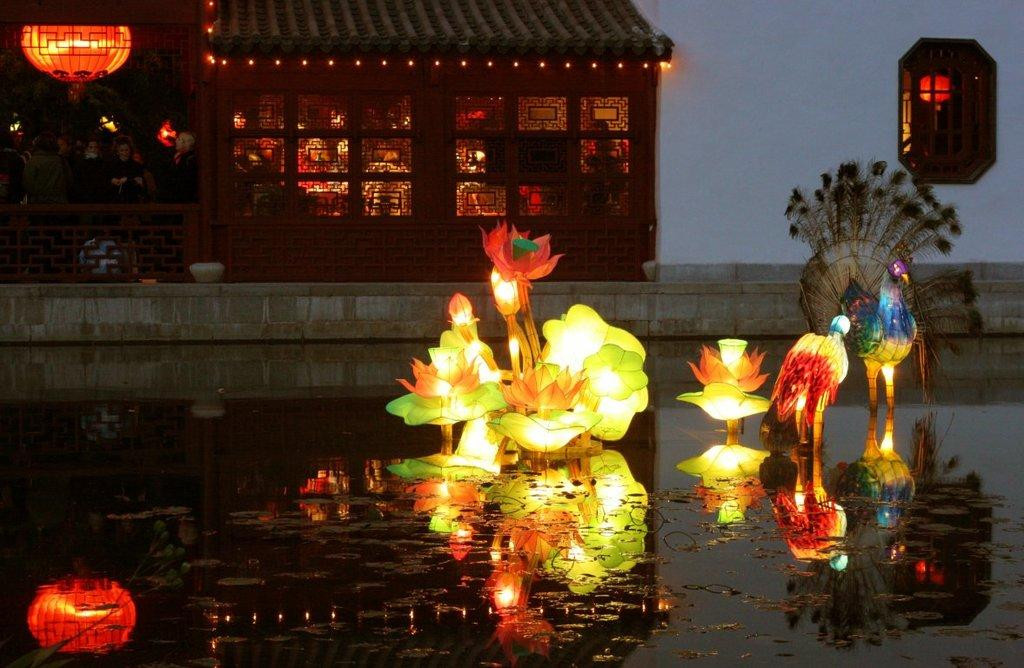What type of decorations can be seen in the picture? There are light decoration items in the picture. What natural element is visible in the picture? There is water visible in the picture. What can be seen in the background of the picture? There is a wall and a house in the background of the picture. How many cards are being played at the top of the image? There are no cards present in the image; it features light decoration items, water, and a wall and house in the background. 